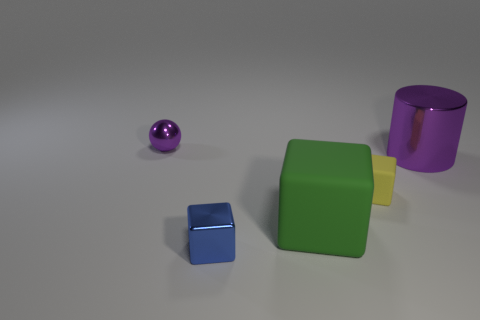Subtract all green matte blocks. How many blocks are left? 2 Subtract all blue blocks. How many blocks are left? 2 Add 5 small green matte cubes. How many objects exist? 10 Subtract all spheres. How many objects are left? 4 Add 3 large purple shiny objects. How many large purple shiny objects exist? 4 Subtract 0 cyan spheres. How many objects are left? 5 Subtract 1 cubes. How many cubes are left? 2 Subtract all cyan cubes. Subtract all purple cylinders. How many cubes are left? 3 Subtract all tiny matte cubes. Subtract all small cyan metal cubes. How many objects are left? 4 Add 4 small purple objects. How many small purple objects are left? 5 